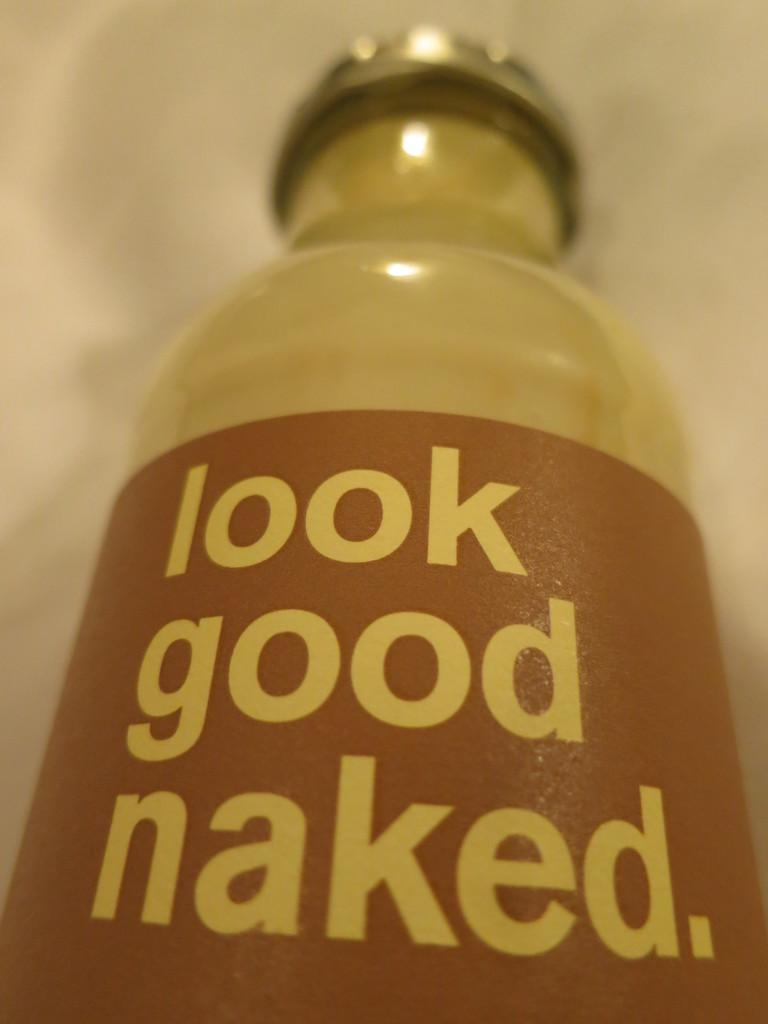<image>
Provide a brief description of the given image. The bottle has a sticker that reads Look Good Naked 